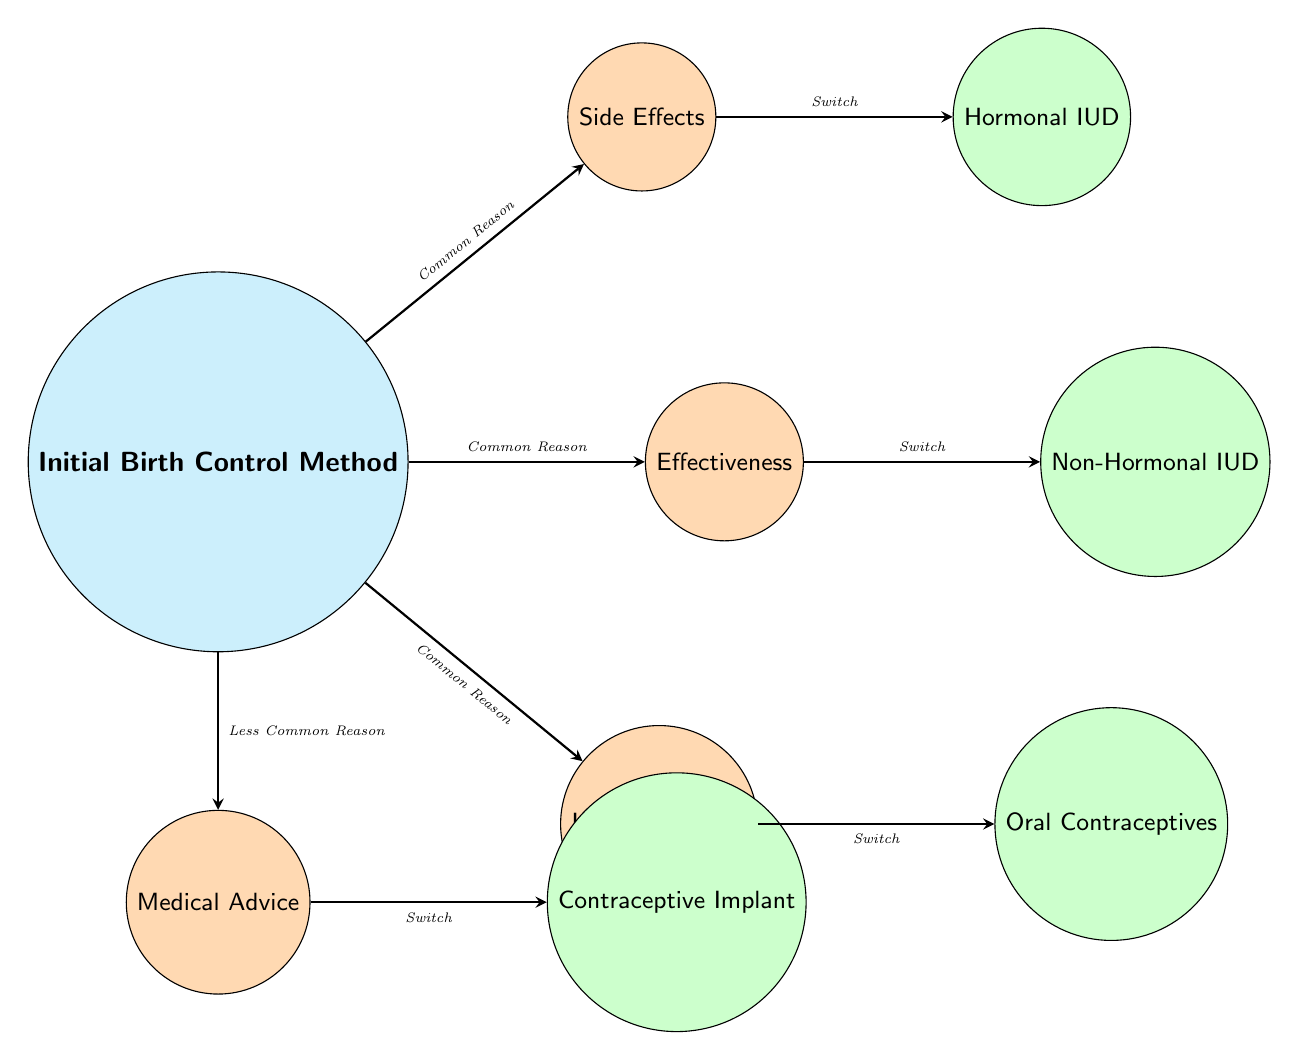What are the initial reasons for switching birth control methods? The diagram lists four reasons: Side Effects, Effectiveness, Lifestyle Change, and Medical Advice. These reasons are connected to the initial birth control method.
Answer: Side Effects, Effectiveness, Lifestyle Change, Medical Advice How many common reasons are depicted in the diagram? The diagram specifies that there are three common reasons: Side Effects, Effectiveness, and Lifestyle Change. Common reasons are indicated by the label 'Common Reason' on the connecting edges.
Answer: 3 Which birth control method is associated with the reason 'Medical Advice'? The diagram shows that the birth control method associated with Medical Advice is the Contraceptive Implant, as indicated by the connection from the reason node to the method node.
Answer: Contraceptive Implant What type of birth control method is linked to the reason 'Effectiveness'? The method linked to Effectiveness is the Non-Hormonal IUD, based on the direct connection illustrated in the diagram from the reason node to the method node.
Answer: Non-Hormonal IUD Which reason for switching is indicated as less common? The diagram points out that Medical Advice is labeled as a 'Less Common Reason' in comparison to the other reasons, which are marked as 'Common Reason.'
Answer: Medical Advice How many edges originate from the initial birth control method? Analyzing the diagram, we can see that four edges originate from the Initial Birth Control Method, connecting it to the reasons for switching.
Answer: 4 Which method is connected to the reason 'Lifestyle Change'? According to the diagram, the method connected to Lifestyle Change is the Oral Contraceptives, as represented by the line connecting the reason node to the method node.
Answer: Oral Contraceptives What is the relationship between the Initial Birth Control Method and the reasons for switching? The relationship is that the Initial Birth Control Method connects to four reasons for switching, showing the influence of initial choice on future decisions.
Answer: Connections to reasons What does the term 'Common Reason' indicate in the context of this diagram? The term 'Common Reason' indicates reasons that are frequent among individuals when switching birth control methods as denoted by the labeling on the edges connecting to those reasons.
Answer: Frequent reasons 